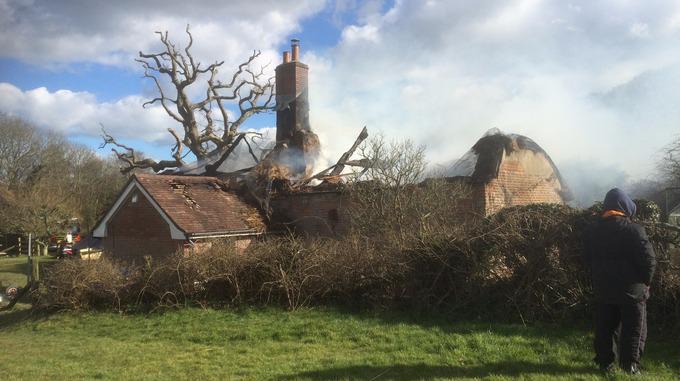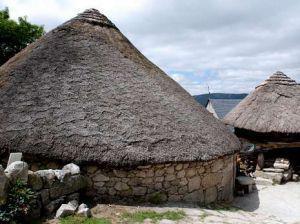The first image is the image on the left, the second image is the image on the right. Examine the images to the left and right. Is the description "In one image, a dwelling has a thatched roof over walls made of rows of stacked rocks." accurate? Answer yes or no. Yes. The first image is the image on the left, the second image is the image on the right. For the images displayed, is the sentence "At least one person is standing on the ground outside of a building in one of the images." factually correct? Answer yes or no. Yes. 